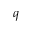Convert formula to latex. <formula><loc_0><loc_0><loc_500><loc_500>q</formula> 